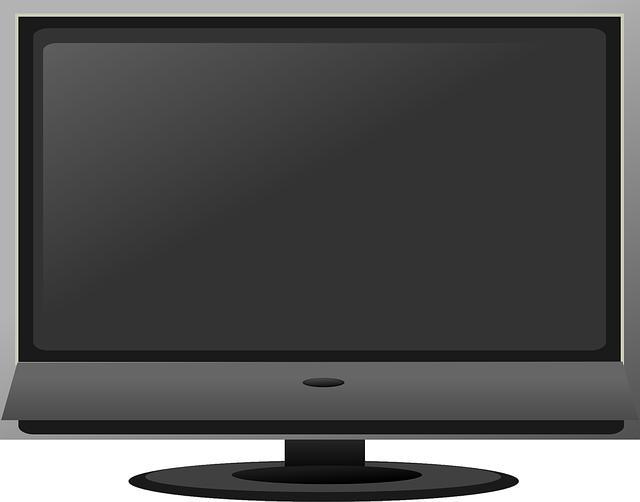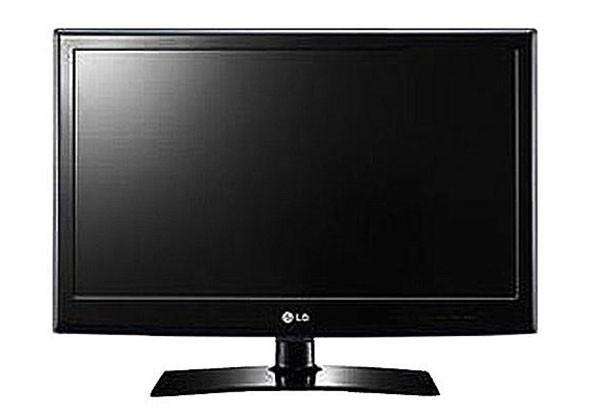The first image is the image on the left, the second image is the image on the right. Considering the images on both sides, is "The right image contains one flat screen television that is turned off." valid? Answer yes or no. Yes. The first image is the image on the left, the second image is the image on the right. For the images shown, is this caption "One of the images has no human." true? Answer yes or no. Yes. 